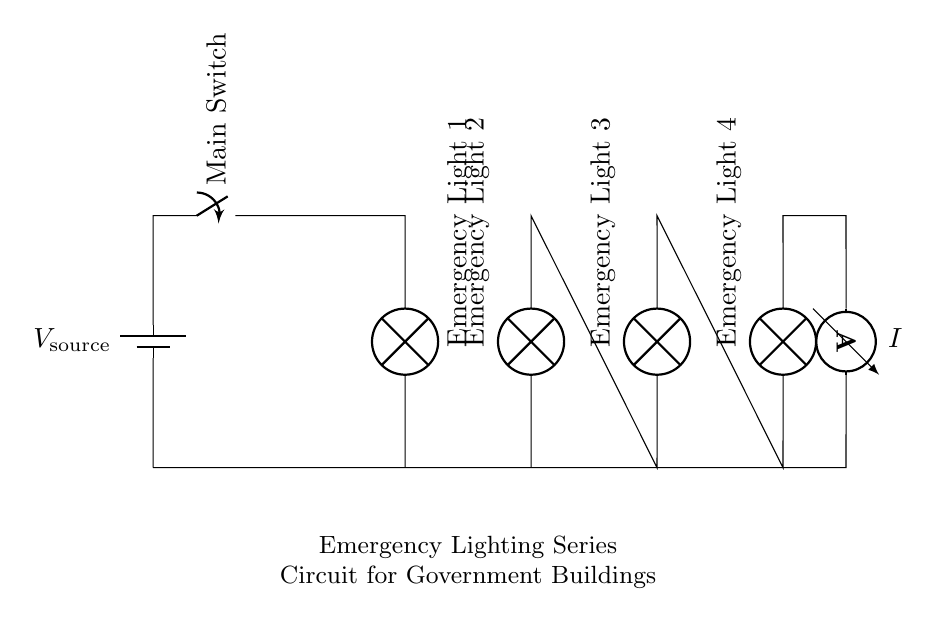What is the power source of this circuit? The circuit diagram shows a battery connected at the top. Batteries serve as a portable power source for the circuit.
Answer: Battery How many emergency lights are in this circuit? Counting the lamps in the diagram, there are four lamps depicted, each representing an emergency light.
Answer: Four What is the function of the switch in this circuit? The switch acts as a control mechanism that can open or close the circuit, allowing or stopping current flow to the emergency lights.
Answer: Control What is the current flowing through the circuit? The ammeter indicated in the diagram measures the current. The specific current value is not given, but it represents the flow through all components in series.
Answer: I If one emergency light fails, what happens to the others? In a series circuit, if one component fails (like an emergency light), all other components lose power, causing them to turn off as well since the circuit is open.
Answer: Off What is the total resistance of this series circuit? The total resistance in a series circuit is the sum of the individual resistances of each component. However, the actual values of resistance for the emergency lights are not provided in the diagram.
Answer: Sum of resistances How does the configuration of this circuit affect voltage distribution? In a series circuit, the voltage from the source is divided among all the components based on their resistance. Therefore, each emergency light will receive a portion of the total voltage from the battery.
Answer: Divided 